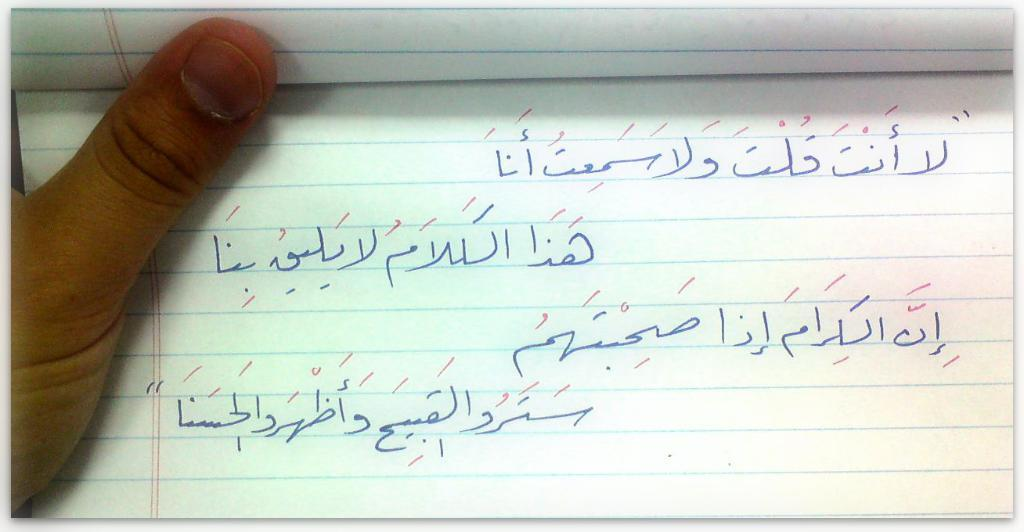What is the main subject of the image? There is a person in the center of the image. What is the person holding in the image? The person is holding a book. What can be found inside the book? The book contains text. What type of pleasure can be seen on the person's face while reading the book in the image? There is no indication of the person's facial expression or emotions in the image, so it cannot be determined if they are experiencing pleasure while reading the book. 